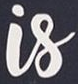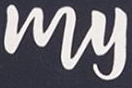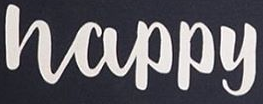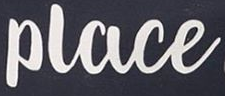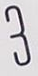What text is displayed in these images sequentially, separated by a semicolon? Is; My; Happy; Place; 3 